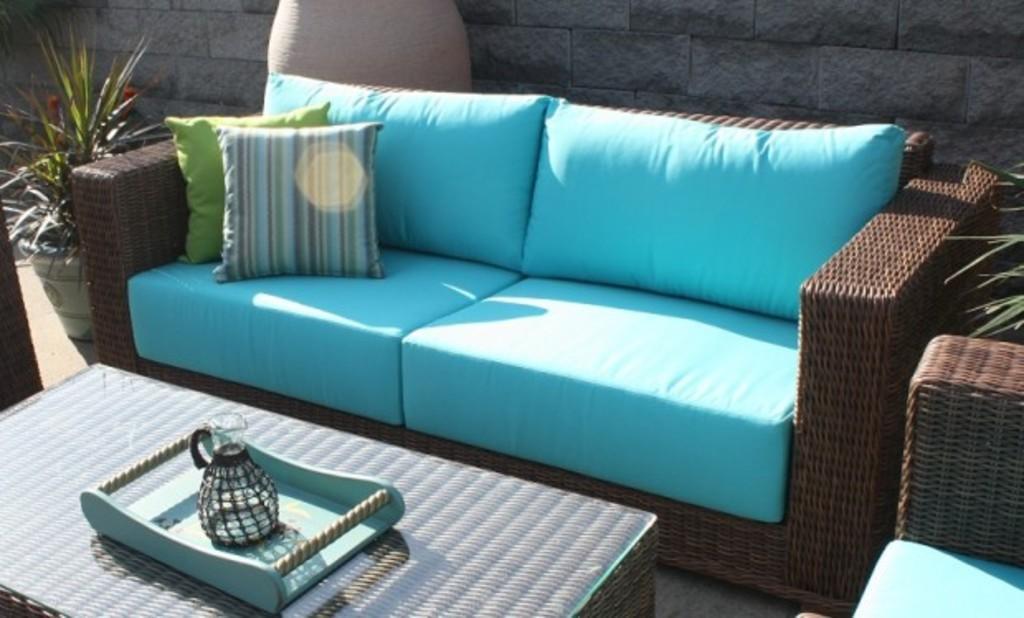Could you give a brief overview of what you see in this image? There is a table, tray, jug on it, sofa, cushions and plant. 